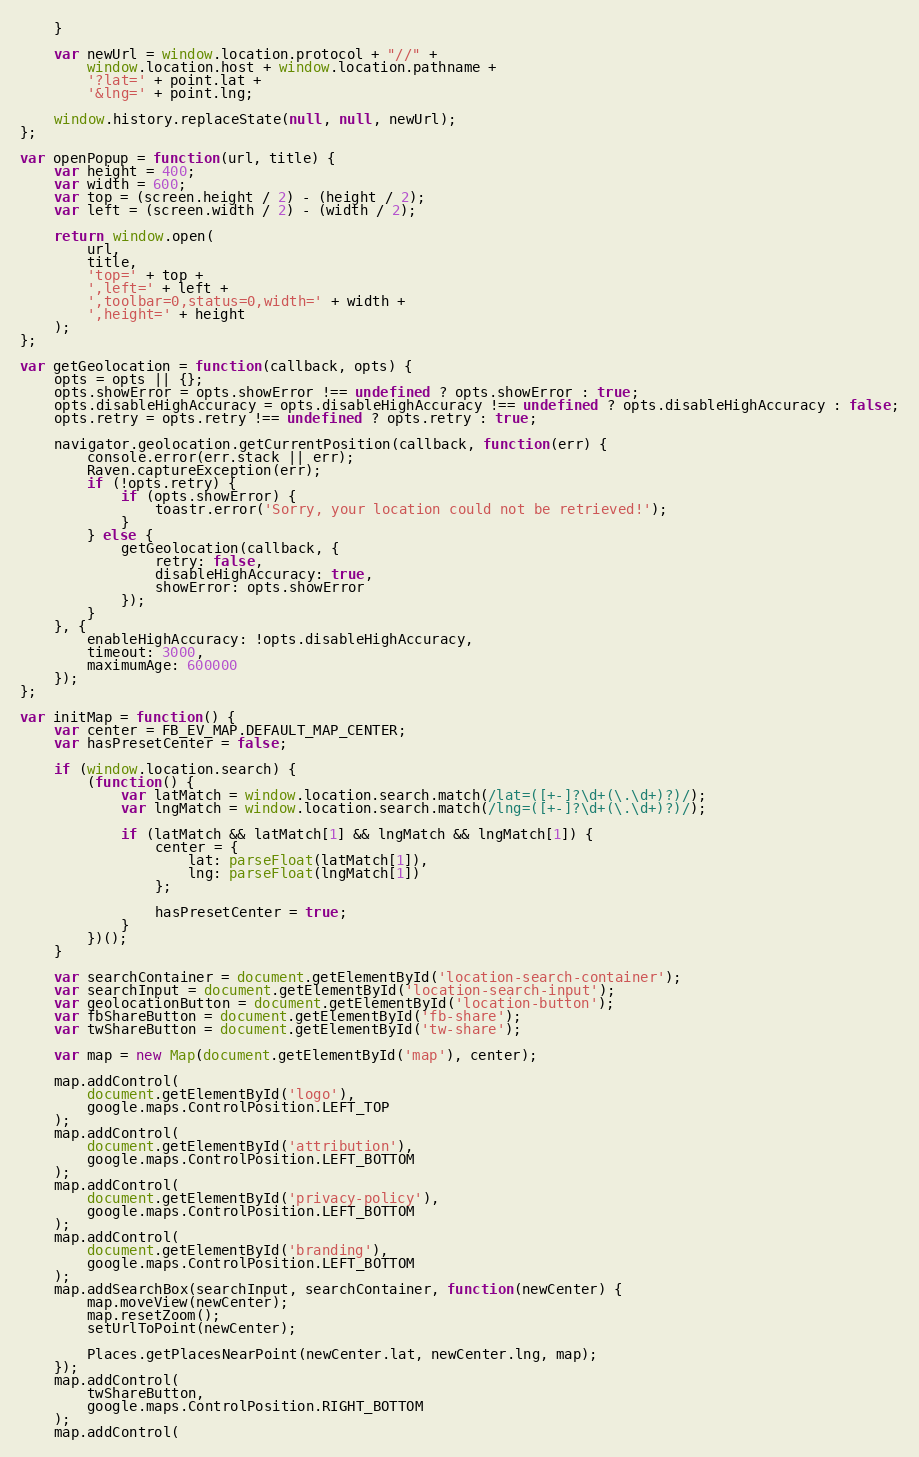Convert code to text. <code><loc_0><loc_0><loc_500><loc_500><_JavaScript_>	}

	var newUrl = window.location.protocol + "//" +
		window.location.host + window.location.pathname +
		'?lat=' + point.lat +
		'&lng=' + point.lng;

	window.history.replaceState(null, null, newUrl);
};

var openPopup = function(url, title) {
	var height = 400;
	var width = 600;
	var top = (screen.height / 2) - (height / 2);
	var left = (screen.width / 2) - (width / 2);

	return window.open(
		url,
		title,
		'top=' + top +
		',left=' + left +
		',toolbar=0,status=0,width=' + width +
		',height=' + height
	);
};

var getGeolocation = function(callback, opts) {
	opts = opts || {};
	opts.showError = opts.showError !== undefined ? opts.showError : true;
	opts.disableHighAccuracy = opts.disableHighAccuracy !== undefined ? opts.disableHighAccuracy : false;
	opts.retry = opts.retry !== undefined ? opts.retry : true;

	navigator.geolocation.getCurrentPosition(callback, function(err) {
		console.error(err.stack || err);
		Raven.captureException(err);
		if (!opts.retry) {
			if (opts.showError) {
				toastr.error('Sorry, your location could not be retrieved!');
			}
		} else {
			getGeolocation(callback, {
				retry: false,
				disableHighAccuracy: true,
				showError: opts.showError
			});
		}
	}, {
		enableHighAccuracy: !opts.disableHighAccuracy,
		timeout: 3000,
		maximumAge: 600000
	});
};

var initMap = function() {
	var center = FB_EV_MAP.DEFAULT_MAP_CENTER;
	var hasPresetCenter = false;

	if (window.location.search) {
		(function() {
			var latMatch = window.location.search.match(/lat=([+-]?\d+(\.\d+)?)/);
			var lngMatch = window.location.search.match(/lng=([+-]?\d+(\.\d+)?)/);

			if (latMatch && latMatch[1] && lngMatch && lngMatch[1]) {
				center = {
					lat: parseFloat(latMatch[1]),
					lng: parseFloat(lngMatch[1])
				};

				hasPresetCenter = true;
			}
		})();
	}

	var searchContainer = document.getElementById('location-search-container');
	var searchInput = document.getElementById('location-search-input');
	var geolocationButton = document.getElementById('location-button');
	var fbShareButton = document.getElementById('fb-share');
	var twShareButton = document.getElementById('tw-share');

	var map = new Map(document.getElementById('map'), center);

	map.addControl(
		document.getElementById('logo'),
		google.maps.ControlPosition.LEFT_TOP
	);
	map.addControl(
		document.getElementById('attribution'),
		google.maps.ControlPosition.LEFT_BOTTOM
	);
	map.addControl(
		document.getElementById('privacy-policy'),
		google.maps.ControlPosition.LEFT_BOTTOM
	);
	map.addControl(
		document.getElementById('branding'),
		google.maps.ControlPosition.LEFT_BOTTOM
	);
	map.addSearchBox(searchInput, searchContainer, function(newCenter) {
		map.moveView(newCenter);
		map.resetZoom();
		setUrlToPoint(newCenter);

		Places.getPlacesNearPoint(newCenter.lat, newCenter.lng, map);
	});
	map.addControl(
		twShareButton,
		google.maps.ControlPosition.RIGHT_BOTTOM
	);
	map.addControl(</code> 